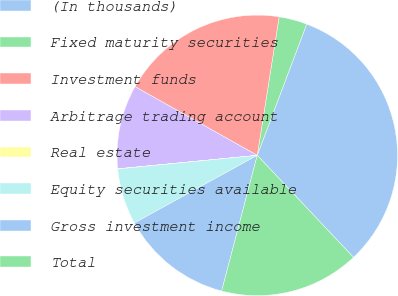<chart> <loc_0><loc_0><loc_500><loc_500><pie_chart><fcel>(In thousands)<fcel>Fixed maturity securities<fcel>Investment funds<fcel>Arbitrage trading account<fcel>Real estate<fcel>Equity securities available<fcel>Gross investment income<fcel>Total<nl><fcel>32.22%<fcel>3.24%<fcel>19.34%<fcel>9.68%<fcel>0.02%<fcel>6.46%<fcel>12.9%<fcel>16.12%<nl></chart> 